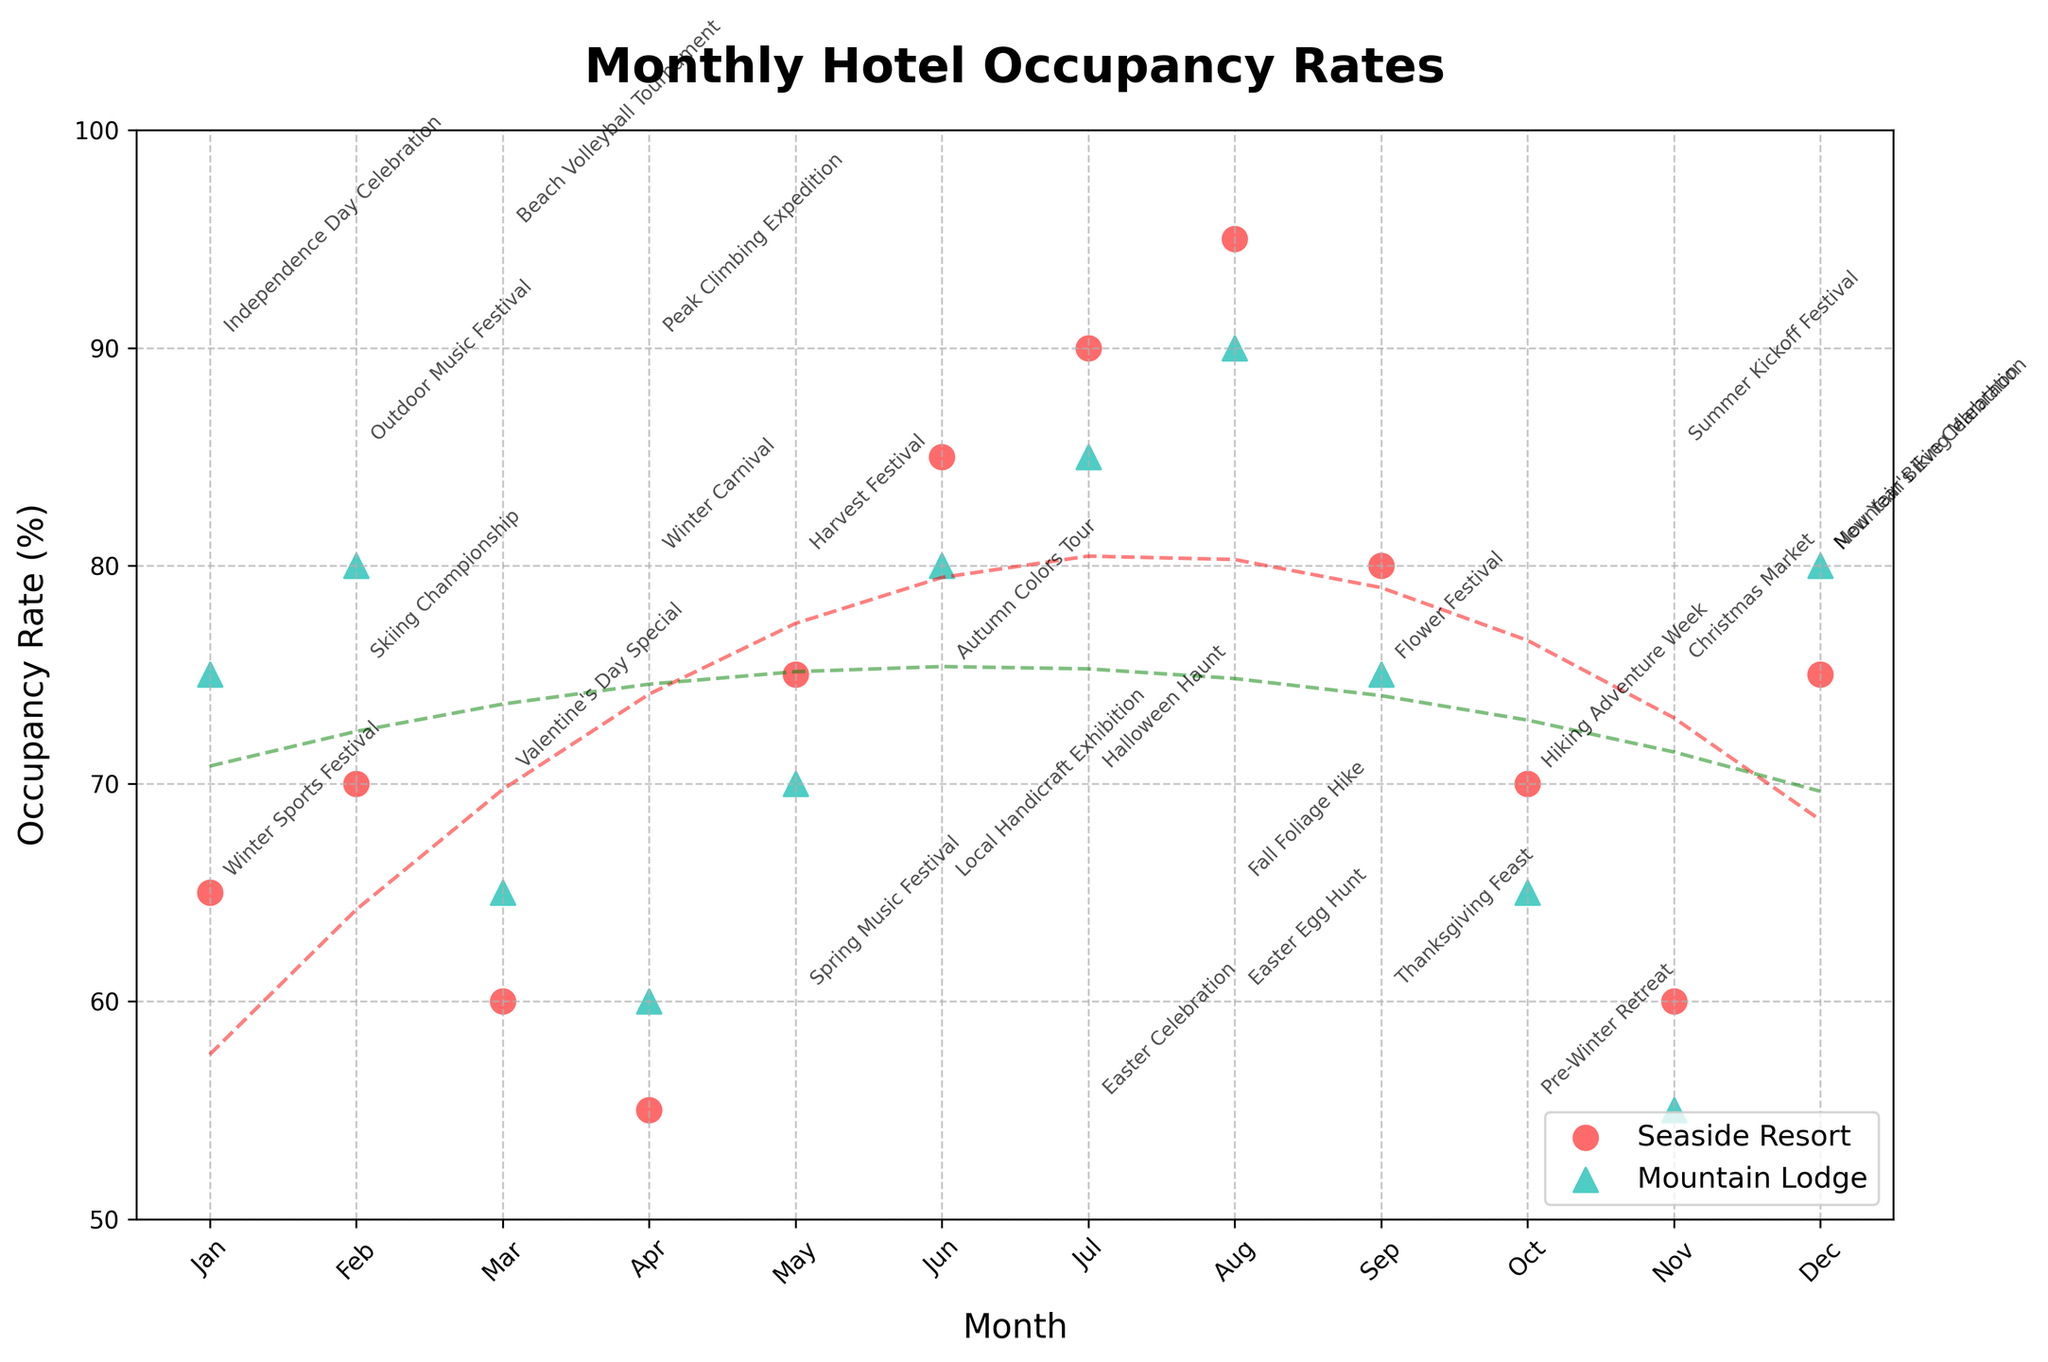what is the title of the figure? The title of the figure is typically located at the top of the plot. In this case, it is clearly labeled to provide an overview of what the plot is about.
Answer: Monthly Hotel Occupancy Rates What do the different markers on the scatter plot represent? The different markers on the scatter plot represent different hotels. Circles represent 'Seaside Resort' and triangles represent 'Mountain Lodge'. This distinction helps in easily identifying data points belonging to each hotel.
Answer: Circles for Seaside Resort, triangles for Mountain Lodge Which month has the highest occupancy rate at the Seaside Resort? By looking at the plot, identify the data point for Seaside Resort with the highest y-axis value. The corresponding month on the x-axis reveals this information.
Answer: August In which month does the Mountain Lodge have a higher occupancy rate than the Seaside Resort? To determine this, compare the occupancy rates of both hotels for each month. Identify the months where the data point for the Mountain Lodge (triangle) is above the data point for the Seaside Resort (circle).
Answer: March, April, November, December When does the Seaside Resort reach its lowest occupancy rate? To find this, look for the data point for the Seaside Resort that corresponds to the lowest y-axis value. The x-axis value will indicate the month.
Answer: April Is there a visible trend in the occupancy rates for Seaside Resort over the months? To understand the trend, observe the overall direction of the dotted red trend line for the Seaside Resort. Determine whether it is increasing, decreasing, or remaining constant.
Answer: Increasing Compare the highest occupancy rates of both hotels. Which hotel has the higher peak, and what are the corresponding rates? Locate the highest points for both Seaside Resort and Mountain Lodge on the plot. Compare their y-axis values to determine which is higher and note the rates.
Answer: Seaside Resort with 95% in August; Mountain Lodge with 90% in August How do the occupancy rates for both hotels compare in December? Check the data points for Seaside Resort and Mountain Lodge in December on the x-axis. Compare their y-axis values to see which has a higher occupancy rate.
Answer: Mountain Lodge has higher occupancy in December (80% vs 75%) What can you infer about the impact of events on hotel occupancy rates? Analyze the annotations indicating events while observing the corresponding occupancy rates. Notice any patterns where specific events coincide with peaks or dips in occupancy rates.
Answer: Events seem to have a positive impact on occupancy rates What is the general trend for Mountain Lodge's occupancy rates throughout the year? Observe the dotted green trend line for Mountain Lodge to determine if it is generally moving upwards, downwards, or remaining relatively constant.
Answer: Increasing 